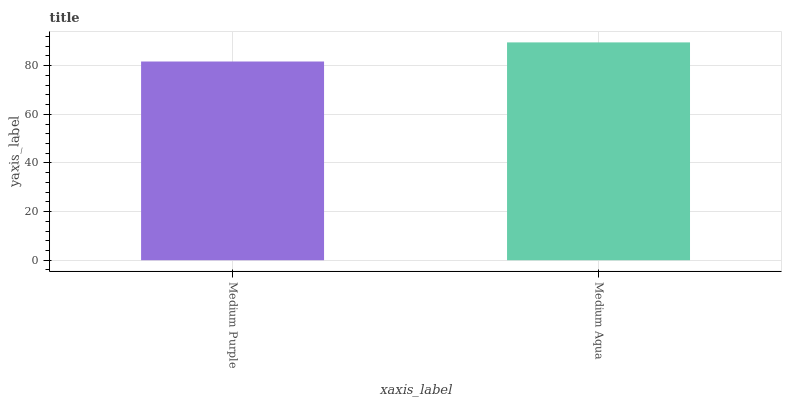Is Medium Purple the minimum?
Answer yes or no. Yes. Is Medium Aqua the maximum?
Answer yes or no. Yes. Is Medium Aqua the minimum?
Answer yes or no. No. Is Medium Aqua greater than Medium Purple?
Answer yes or no. Yes. Is Medium Purple less than Medium Aqua?
Answer yes or no. Yes. Is Medium Purple greater than Medium Aqua?
Answer yes or no. No. Is Medium Aqua less than Medium Purple?
Answer yes or no. No. Is Medium Aqua the high median?
Answer yes or no. Yes. Is Medium Purple the low median?
Answer yes or no. Yes. Is Medium Purple the high median?
Answer yes or no. No. Is Medium Aqua the low median?
Answer yes or no. No. 